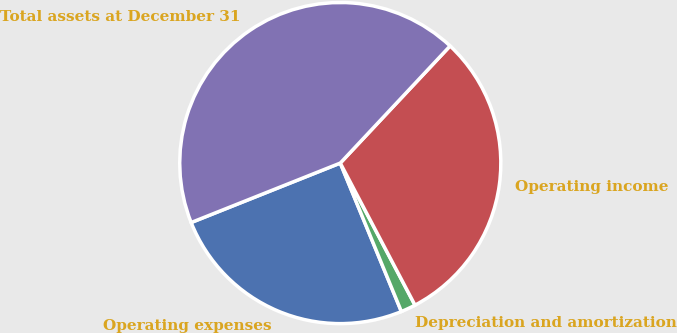Convert chart to OTSL. <chart><loc_0><loc_0><loc_500><loc_500><pie_chart><fcel>Operating expenses<fcel>Depreciation and amortization<fcel>Operating income<fcel>Total assets at December 31<nl><fcel>25.18%<fcel>1.49%<fcel>30.31%<fcel>43.03%<nl></chart> 